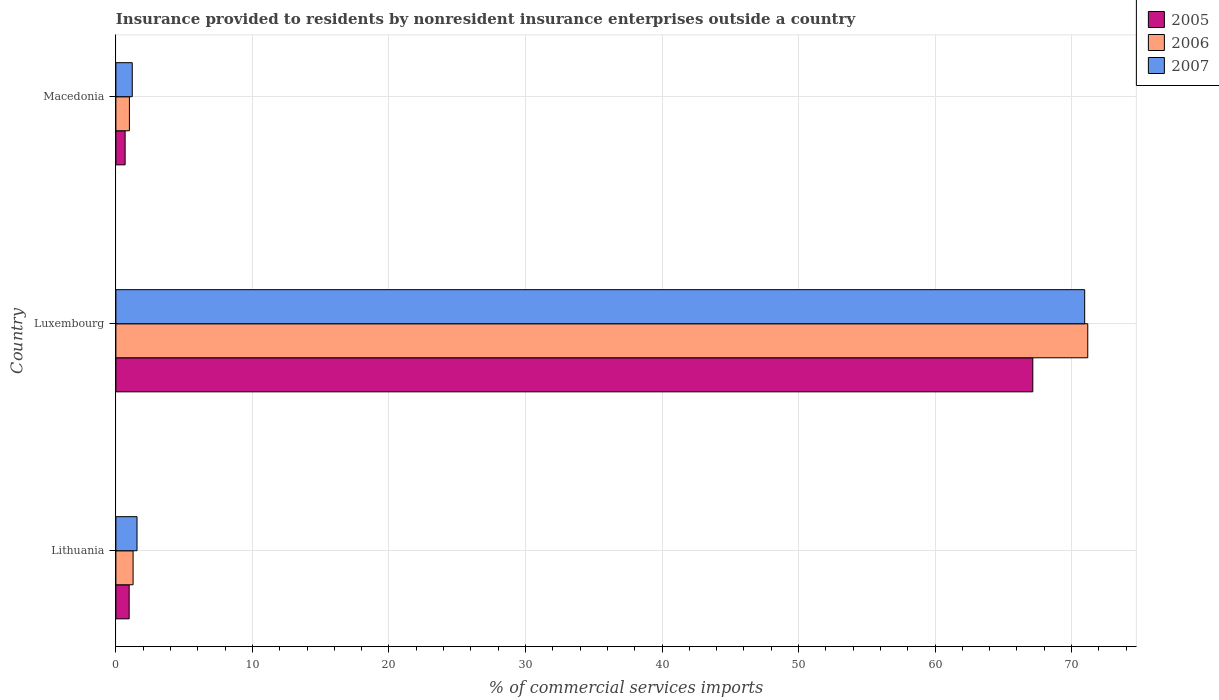Are the number of bars per tick equal to the number of legend labels?
Offer a very short reply. Yes. Are the number of bars on each tick of the Y-axis equal?
Your answer should be compact. Yes. How many bars are there on the 3rd tick from the bottom?
Make the answer very short. 3. What is the label of the 2nd group of bars from the top?
Offer a terse response. Luxembourg. In how many cases, is the number of bars for a given country not equal to the number of legend labels?
Offer a very short reply. 0. What is the Insurance provided to residents in 2007 in Luxembourg?
Keep it short and to the point. 70.96. Across all countries, what is the maximum Insurance provided to residents in 2007?
Offer a very short reply. 70.96. Across all countries, what is the minimum Insurance provided to residents in 2006?
Provide a short and direct response. 0.99. In which country was the Insurance provided to residents in 2006 maximum?
Your answer should be very brief. Luxembourg. In which country was the Insurance provided to residents in 2007 minimum?
Offer a terse response. Macedonia. What is the total Insurance provided to residents in 2006 in the graph?
Offer a terse response. 73.44. What is the difference between the Insurance provided to residents in 2007 in Lithuania and that in Macedonia?
Make the answer very short. 0.35. What is the difference between the Insurance provided to residents in 2007 in Luxembourg and the Insurance provided to residents in 2006 in Macedonia?
Your answer should be very brief. 69.97. What is the average Insurance provided to residents in 2007 per country?
Your answer should be very brief. 24.57. What is the difference between the Insurance provided to residents in 2007 and Insurance provided to residents in 2006 in Luxembourg?
Offer a terse response. -0.23. In how many countries, is the Insurance provided to residents in 2007 greater than 22 %?
Your response must be concise. 1. What is the ratio of the Insurance provided to residents in 2006 in Lithuania to that in Macedonia?
Offer a very short reply. 1.27. Is the difference between the Insurance provided to residents in 2007 in Luxembourg and Macedonia greater than the difference between the Insurance provided to residents in 2006 in Luxembourg and Macedonia?
Your response must be concise. No. What is the difference between the highest and the second highest Insurance provided to residents in 2005?
Your answer should be very brief. 66.19. What is the difference between the highest and the lowest Insurance provided to residents in 2007?
Your response must be concise. 69.76. In how many countries, is the Insurance provided to residents in 2007 greater than the average Insurance provided to residents in 2007 taken over all countries?
Give a very brief answer. 1. Is the sum of the Insurance provided to residents in 2007 in Lithuania and Luxembourg greater than the maximum Insurance provided to residents in 2005 across all countries?
Ensure brevity in your answer.  Yes. Is it the case that in every country, the sum of the Insurance provided to residents in 2005 and Insurance provided to residents in 2007 is greater than the Insurance provided to residents in 2006?
Offer a very short reply. Yes. How many countries are there in the graph?
Provide a short and direct response. 3. How many legend labels are there?
Provide a succinct answer. 3. How are the legend labels stacked?
Offer a very short reply. Vertical. What is the title of the graph?
Your answer should be compact. Insurance provided to residents by nonresident insurance enterprises outside a country. What is the label or title of the X-axis?
Offer a very short reply. % of commercial services imports. What is the label or title of the Y-axis?
Your response must be concise. Country. What is the % of commercial services imports in 2005 in Lithuania?
Your response must be concise. 0.97. What is the % of commercial services imports of 2006 in Lithuania?
Provide a succinct answer. 1.26. What is the % of commercial services imports of 2007 in Lithuania?
Offer a terse response. 1.55. What is the % of commercial services imports in 2005 in Luxembourg?
Provide a succinct answer. 67.16. What is the % of commercial services imports in 2006 in Luxembourg?
Your response must be concise. 71.19. What is the % of commercial services imports of 2007 in Luxembourg?
Provide a succinct answer. 70.96. What is the % of commercial services imports in 2005 in Macedonia?
Offer a terse response. 0.68. What is the % of commercial services imports in 2006 in Macedonia?
Make the answer very short. 0.99. What is the % of commercial services imports in 2007 in Macedonia?
Your answer should be very brief. 1.2. Across all countries, what is the maximum % of commercial services imports of 2005?
Your response must be concise. 67.16. Across all countries, what is the maximum % of commercial services imports of 2006?
Provide a succinct answer. 71.19. Across all countries, what is the maximum % of commercial services imports in 2007?
Provide a succinct answer. 70.96. Across all countries, what is the minimum % of commercial services imports of 2005?
Your response must be concise. 0.68. Across all countries, what is the minimum % of commercial services imports in 2006?
Offer a very short reply. 0.99. Across all countries, what is the minimum % of commercial services imports of 2007?
Provide a succinct answer. 1.2. What is the total % of commercial services imports of 2005 in the graph?
Give a very brief answer. 68.81. What is the total % of commercial services imports in 2006 in the graph?
Your answer should be compact. 73.44. What is the total % of commercial services imports in 2007 in the graph?
Keep it short and to the point. 73.7. What is the difference between the % of commercial services imports of 2005 in Lithuania and that in Luxembourg?
Offer a very short reply. -66.19. What is the difference between the % of commercial services imports of 2006 in Lithuania and that in Luxembourg?
Provide a succinct answer. -69.92. What is the difference between the % of commercial services imports in 2007 in Lithuania and that in Luxembourg?
Provide a short and direct response. -69.41. What is the difference between the % of commercial services imports in 2005 in Lithuania and that in Macedonia?
Keep it short and to the point. 0.3. What is the difference between the % of commercial services imports in 2006 in Lithuania and that in Macedonia?
Keep it short and to the point. 0.27. What is the difference between the % of commercial services imports of 2007 in Lithuania and that in Macedonia?
Provide a short and direct response. 0.35. What is the difference between the % of commercial services imports in 2005 in Luxembourg and that in Macedonia?
Ensure brevity in your answer.  66.48. What is the difference between the % of commercial services imports in 2006 in Luxembourg and that in Macedonia?
Offer a very short reply. 70.19. What is the difference between the % of commercial services imports in 2007 in Luxembourg and that in Macedonia?
Provide a short and direct response. 69.76. What is the difference between the % of commercial services imports in 2005 in Lithuania and the % of commercial services imports in 2006 in Luxembourg?
Make the answer very short. -70.21. What is the difference between the % of commercial services imports of 2005 in Lithuania and the % of commercial services imports of 2007 in Luxembourg?
Your response must be concise. -69.99. What is the difference between the % of commercial services imports of 2006 in Lithuania and the % of commercial services imports of 2007 in Luxembourg?
Your answer should be very brief. -69.7. What is the difference between the % of commercial services imports in 2005 in Lithuania and the % of commercial services imports in 2006 in Macedonia?
Provide a succinct answer. -0.02. What is the difference between the % of commercial services imports in 2005 in Lithuania and the % of commercial services imports in 2007 in Macedonia?
Ensure brevity in your answer.  -0.23. What is the difference between the % of commercial services imports of 2006 in Lithuania and the % of commercial services imports of 2007 in Macedonia?
Provide a succinct answer. 0.06. What is the difference between the % of commercial services imports in 2005 in Luxembourg and the % of commercial services imports in 2006 in Macedonia?
Offer a terse response. 66.17. What is the difference between the % of commercial services imports of 2005 in Luxembourg and the % of commercial services imports of 2007 in Macedonia?
Ensure brevity in your answer.  65.96. What is the difference between the % of commercial services imports in 2006 in Luxembourg and the % of commercial services imports in 2007 in Macedonia?
Your response must be concise. 69.99. What is the average % of commercial services imports in 2005 per country?
Your answer should be very brief. 22.94. What is the average % of commercial services imports of 2006 per country?
Your answer should be very brief. 24.48. What is the average % of commercial services imports of 2007 per country?
Give a very brief answer. 24.57. What is the difference between the % of commercial services imports in 2005 and % of commercial services imports in 2006 in Lithuania?
Give a very brief answer. -0.29. What is the difference between the % of commercial services imports in 2005 and % of commercial services imports in 2007 in Lithuania?
Your response must be concise. -0.57. What is the difference between the % of commercial services imports of 2006 and % of commercial services imports of 2007 in Lithuania?
Keep it short and to the point. -0.29. What is the difference between the % of commercial services imports of 2005 and % of commercial services imports of 2006 in Luxembourg?
Give a very brief answer. -4.03. What is the difference between the % of commercial services imports of 2005 and % of commercial services imports of 2007 in Luxembourg?
Keep it short and to the point. -3.8. What is the difference between the % of commercial services imports of 2006 and % of commercial services imports of 2007 in Luxembourg?
Give a very brief answer. 0.23. What is the difference between the % of commercial services imports in 2005 and % of commercial services imports in 2006 in Macedonia?
Offer a terse response. -0.31. What is the difference between the % of commercial services imports in 2005 and % of commercial services imports in 2007 in Macedonia?
Keep it short and to the point. -0.52. What is the difference between the % of commercial services imports in 2006 and % of commercial services imports in 2007 in Macedonia?
Your answer should be very brief. -0.21. What is the ratio of the % of commercial services imports in 2005 in Lithuania to that in Luxembourg?
Provide a succinct answer. 0.01. What is the ratio of the % of commercial services imports in 2006 in Lithuania to that in Luxembourg?
Keep it short and to the point. 0.02. What is the ratio of the % of commercial services imports in 2007 in Lithuania to that in Luxembourg?
Your answer should be compact. 0.02. What is the ratio of the % of commercial services imports in 2005 in Lithuania to that in Macedonia?
Ensure brevity in your answer.  1.44. What is the ratio of the % of commercial services imports of 2006 in Lithuania to that in Macedonia?
Keep it short and to the point. 1.27. What is the ratio of the % of commercial services imports of 2007 in Lithuania to that in Macedonia?
Offer a very short reply. 1.29. What is the ratio of the % of commercial services imports of 2005 in Luxembourg to that in Macedonia?
Keep it short and to the point. 99.34. What is the ratio of the % of commercial services imports in 2006 in Luxembourg to that in Macedonia?
Keep it short and to the point. 71.88. What is the ratio of the % of commercial services imports of 2007 in Luxembourg to that in Macedonia?
Your response must be concise. 59.22. What is the difference between the highest and the second highest % of commercial services imports of 2005?
Give a very brief answer. 66.19. What is the difference between the highest and the second highest % of commercial services imports of 2006?
Your answer should be compact. 69.92. What is the difference between the highest and the second highest % of commercial services imports in 2007?
Your answer should be very brief. 69.41. What is the difference between the highest and the lowest % of commercial services imports of 2005?
Provide a succinct answer. 66.48. What is the difference between the highest and the lowest % of commercial services imports in 2006?
Make the answer very short. 70.19. What is the difference between the highest and the lowest % of commercial services imports of 2007?
Your answer should be very brief. 69.76. 